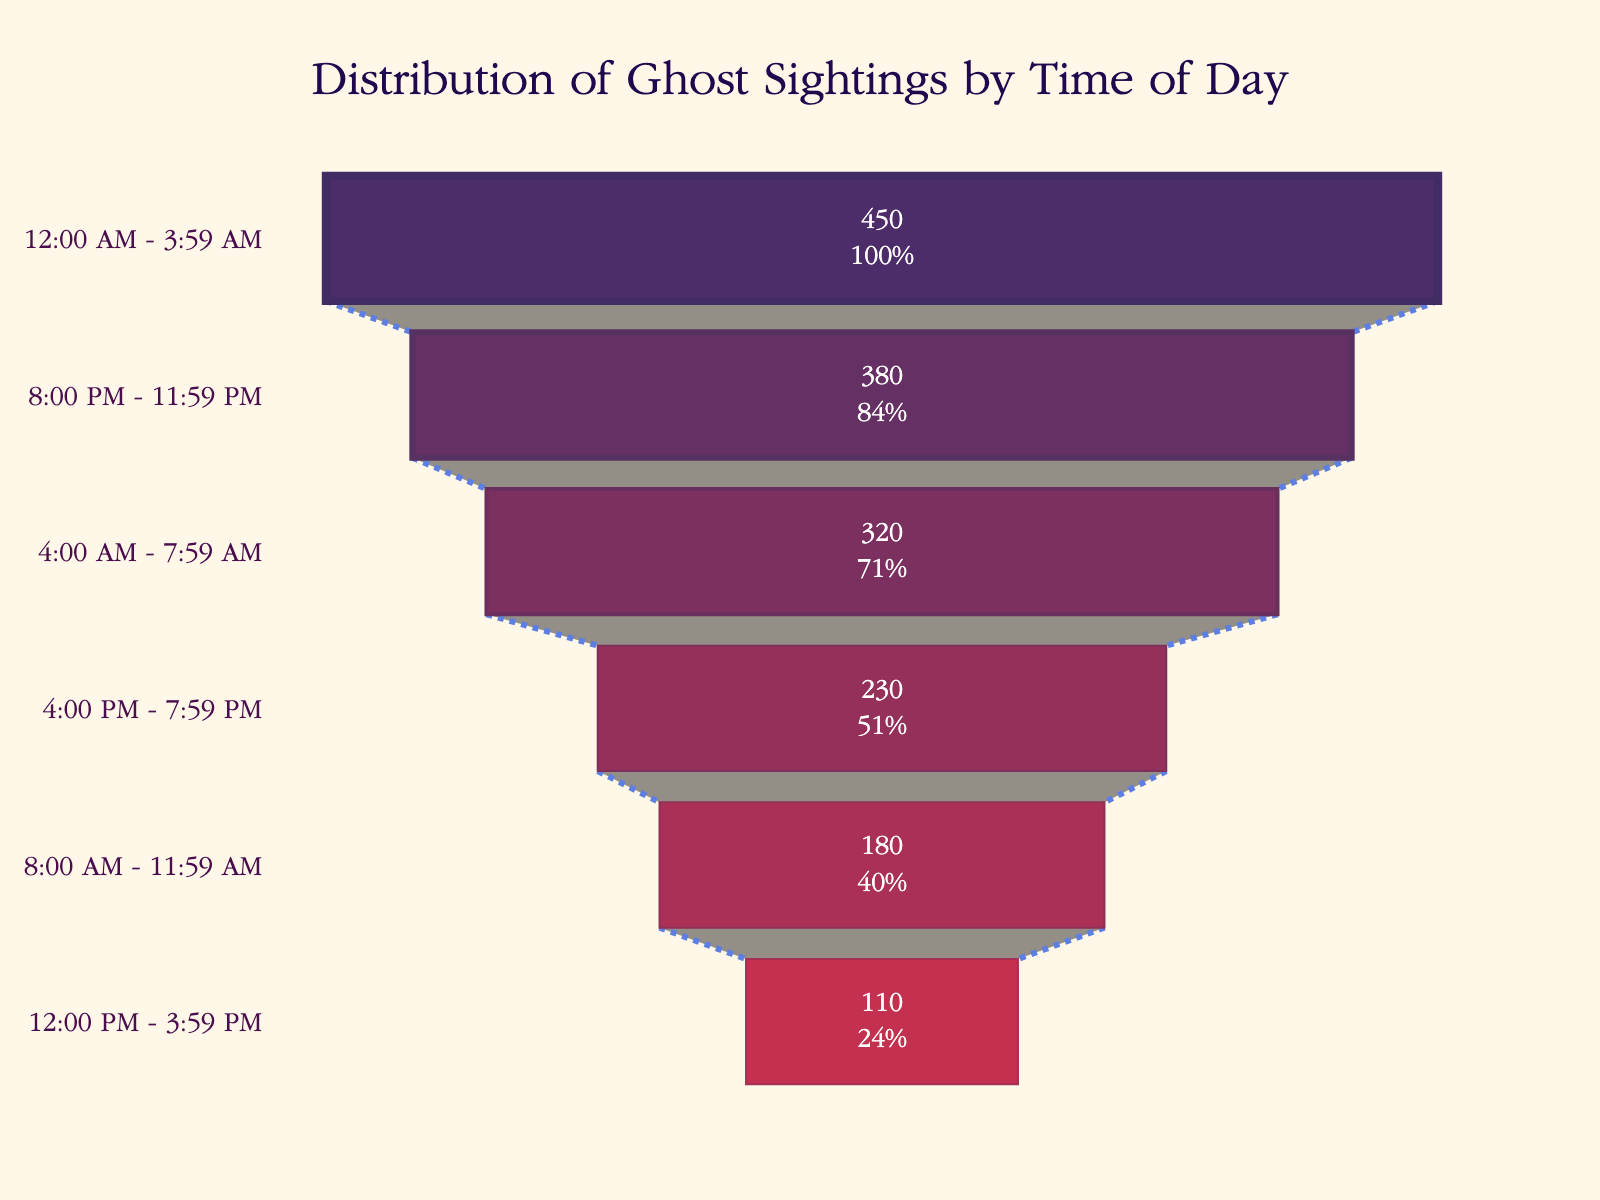What's the title of the funnel chart? The title is often found at the top center of the chart, displaying the primary subject. By looking at the chart, One would see it's titled "Distribution of Ghost Sightings by Time of Day".
Answer: Distribution of Ghost Sightings by Time of Day How many different time periods are displayed in the funnel chart? The chart shows different segments, each representing a time period. By counting these segments, there are six periods displayed.
Answer: Six What time of day has the highest number of reported ghost sightings? In a funnel chart, the largest segment represents the highest value. Here, the segment labeled "12:00 AM - 3:59 AM" is the largest, indicating it has the most sightings.
Answer: 12:00 AM - 3:59 AM What is the total number of ghost sightings reported? To find this, sum all the numbers from each time period in the chart: 450+320+180+110+230+380 = 1670.
Answer: 1670 Which time period has the lowest number of reported ghost sightings? The smallest segment represents the lowest value. The segment labeled "12:00 PM - 3:59 PM" is the smallest, thus having the fewest sightings.
Answer: 12:00 PM - 3:59 PM What percentage of sightings occurred between 4:00 PM and 7:59 PM? To find the percentage, divide the number of sightings in this period by the total number of sightings and multiply by 100. (230 / 1670) * 100 ≈ 13.77%.
Answer: 13.77% Which two adjacent time periods have the biggest difference in the number of reported sightings? Look for the two neighboring segments with the largest difference in size. The difference between "12:00 AM - 3:59 AM" (450) and "4:00 AM - 7:59 AM" (320) is the largest: 450 - 320 = 130.
Answer: 12:00 AM - 3:59 AM & 4:00 AM - 7:59 AM What is the average number of reported ghost sightings per time period? The total number of sightings is 1670, and there are six time periods. So, the average is 1670 / 6 ≈ 278.33.
Answer: 278.33 During which two time periods combined were more than half of all sightings reported? First, find half of 1670, which is 835. By examining the chart, we see that "12:00 AM - 3:59 AM" (450) and "8:00 PM - 11:59 PM" (380) together have 450+380=830, but adding "4:00 AM - 7:59 AM" (320) with "12:00 AM - 3:59 AM" (450) gives us 450+320=770. Adding in 230 from "4:00 PM - 7:59 PM" lets us surpass 835.
Answer: 12:00 AM - 3:59 AM & 4:00 AM - 7:59 AM 